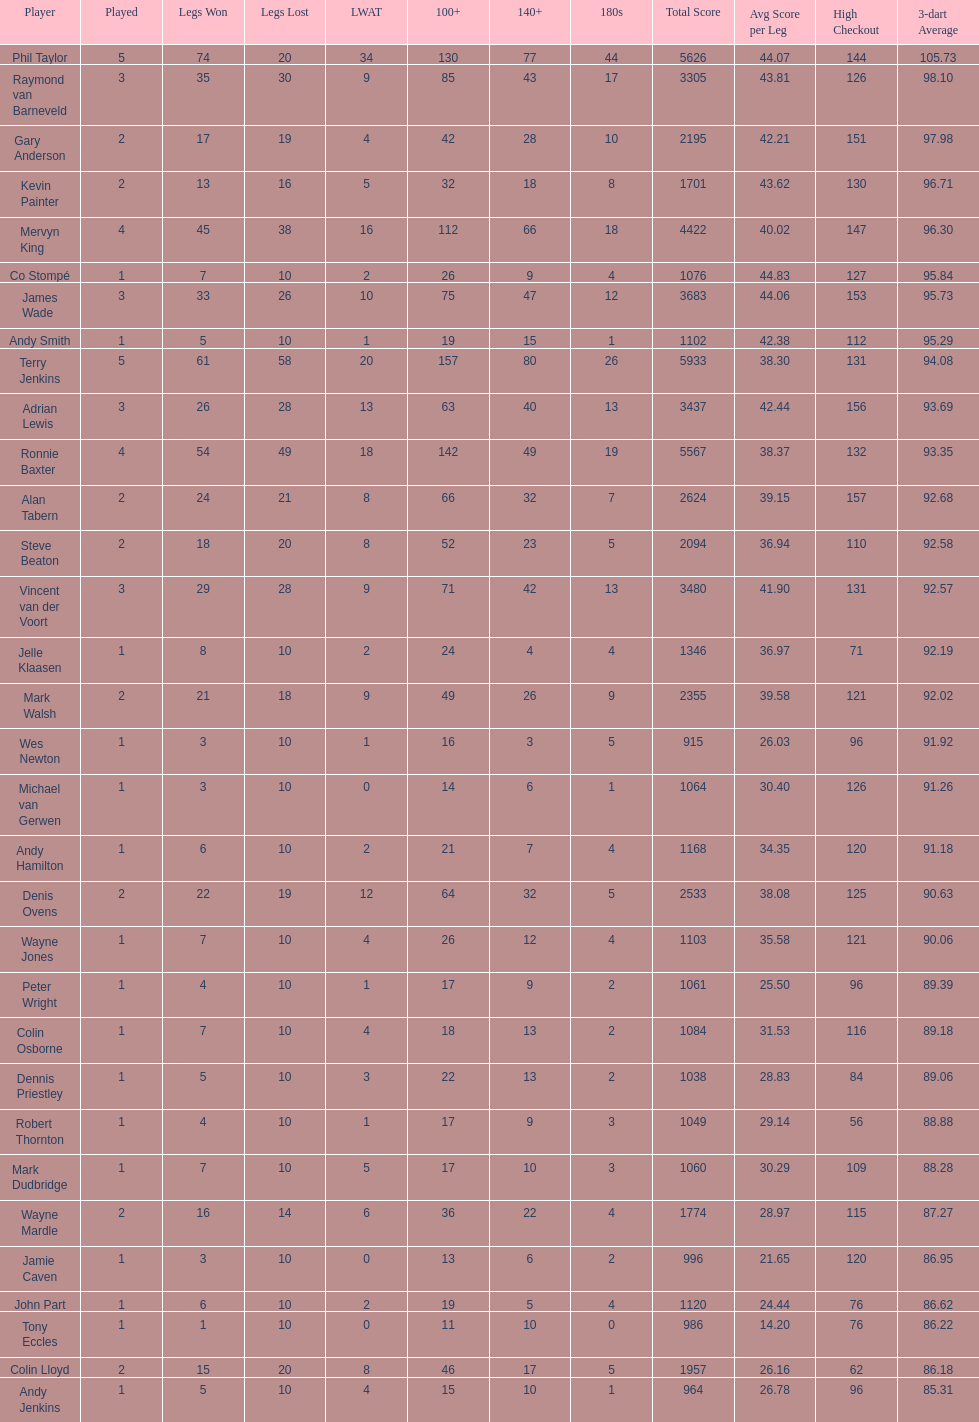What are the number of legs lost by james wade? 26. 